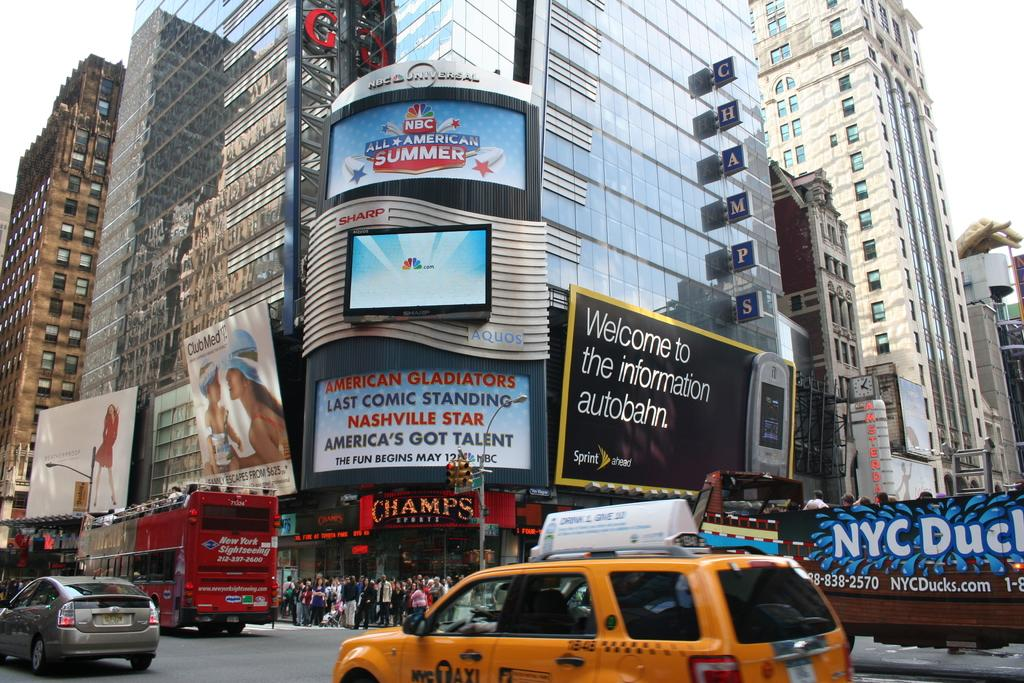<image>
Present a compact description of the photo's key features. a busy street with billboards for Sprint line the road 